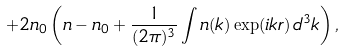Convert formula to latex. <formula><loc_0><loc_0><loc_500><loc_500>+ 2 n _ { 0 } \left ( n - n _ { 0 } + \frac { 1 } { ( 2 \pi ) ^ { 3 } } \int n ( k ) \exp ( i { k } { r } ) \, d ^ { 3 } k \right ) ,</formula> 